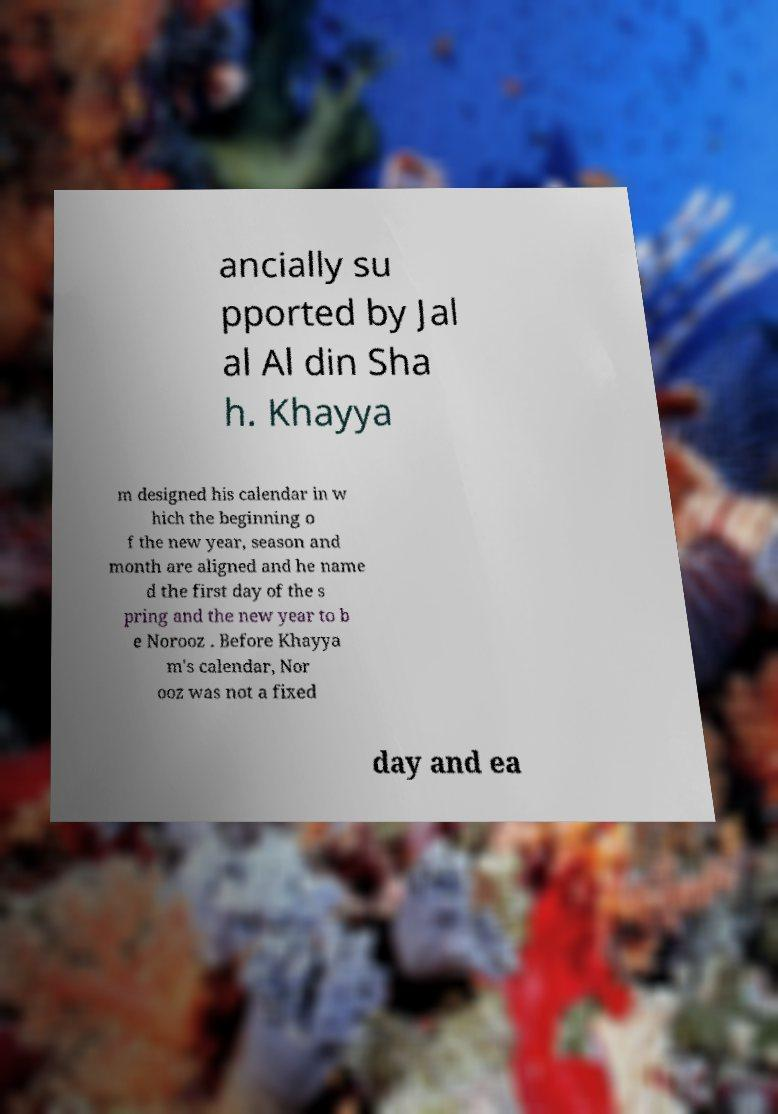Can you read and provide the text displayed in the image?This photo seems to have some interesting text. Can you extract and type it out for me? ancially su pported by Jal al Al din Sha h. Khayya m designed his calendar in w hich the beginning o f the new year, season and month are aligned and he name d the first day of the s pring and the new year to b e Norooz . Before Khayya m's calendar, Nor ooz was not a fixed day and ea 